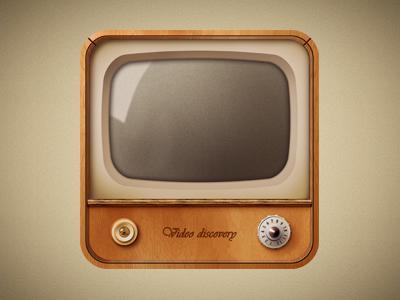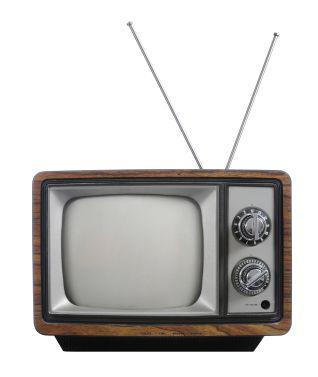The first image is the image on the left, the second image is the image on the right. Considering the images on both sides, is "In at least one image there is a small brown tv with a left and right knobs below the tv screen." valid? Answer yes or no. Yes. The first image is the image on the left, the second image is the image on the right. For the images displayed, is the sentence "One of the TVs has a screen with rounded corners inset in a light brown boxy console with legs." factually correct? Answer yes or no. No. 